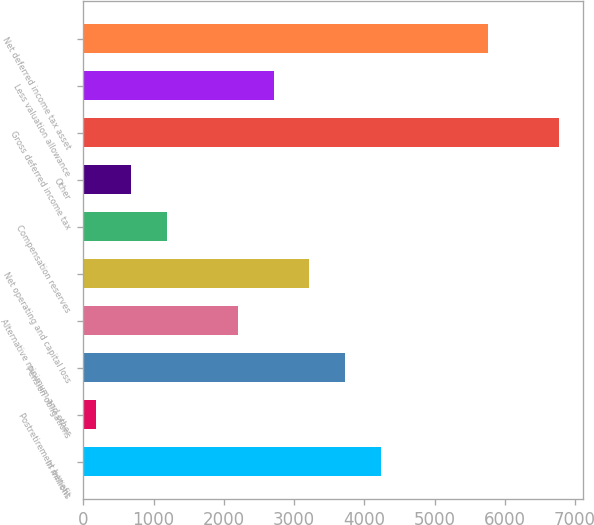<chart> <loc_0><loc_0><loc_500><loc_500><bar_chart><fcel>In millions<fcel>Postretirement benefit<fcel>Pension obligations<fcel>Alternative minimum and other<fcel>Net operating and capital loss<fcel>Compensation reserves<fcel>Other<fcel>Gross deferred income tax<fcel>Less valuation allowance<fcel>Net deferred income tax asset<nl><fcel>4235.2<fcel>172<fcel>3727.3<fcel>2203.6<fcel>3219.4<fcel>1187.8<fcel>679.9<fcel>6774.7<fcel>2711.5<fcel>5758.9<nl></chart> 